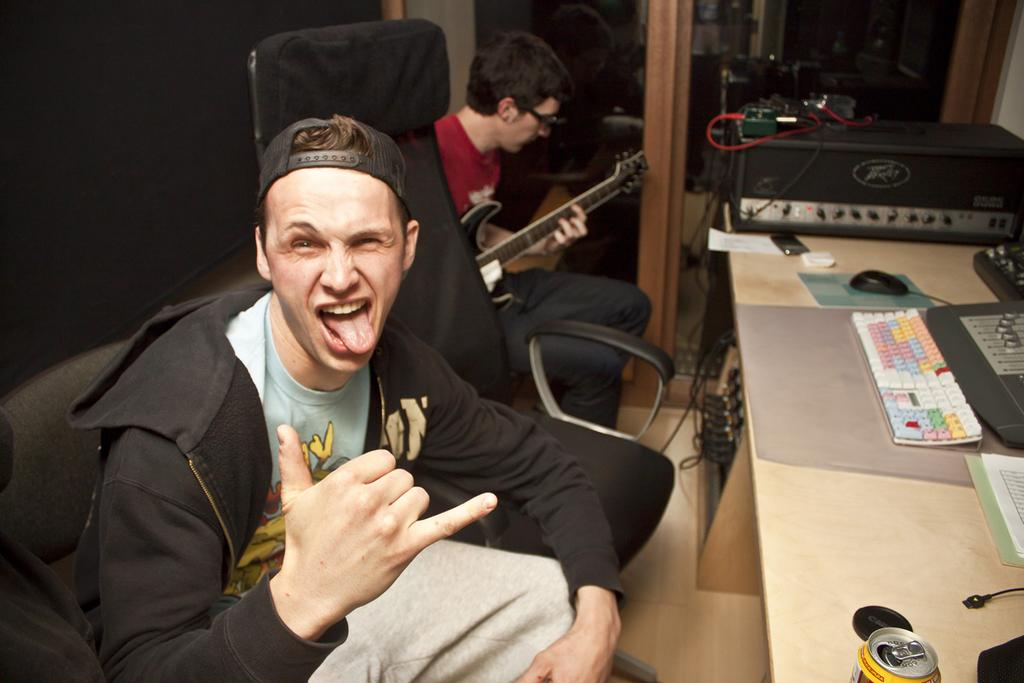How many people are in the image? There are two people in the image. What are the people doing in the image? The people are sitting on chairs. What objects can be seen on the tables in the image? There is a tin, a keyboard, and a mouse on the tables, as well as unspecified items. What type of egg is being taught by the son in the image? There is no egg or son present in the image. What subject is the son teaching the egg in the image? There is no egg or son present in the image, so it is not possible to determine what subject might be taught. 